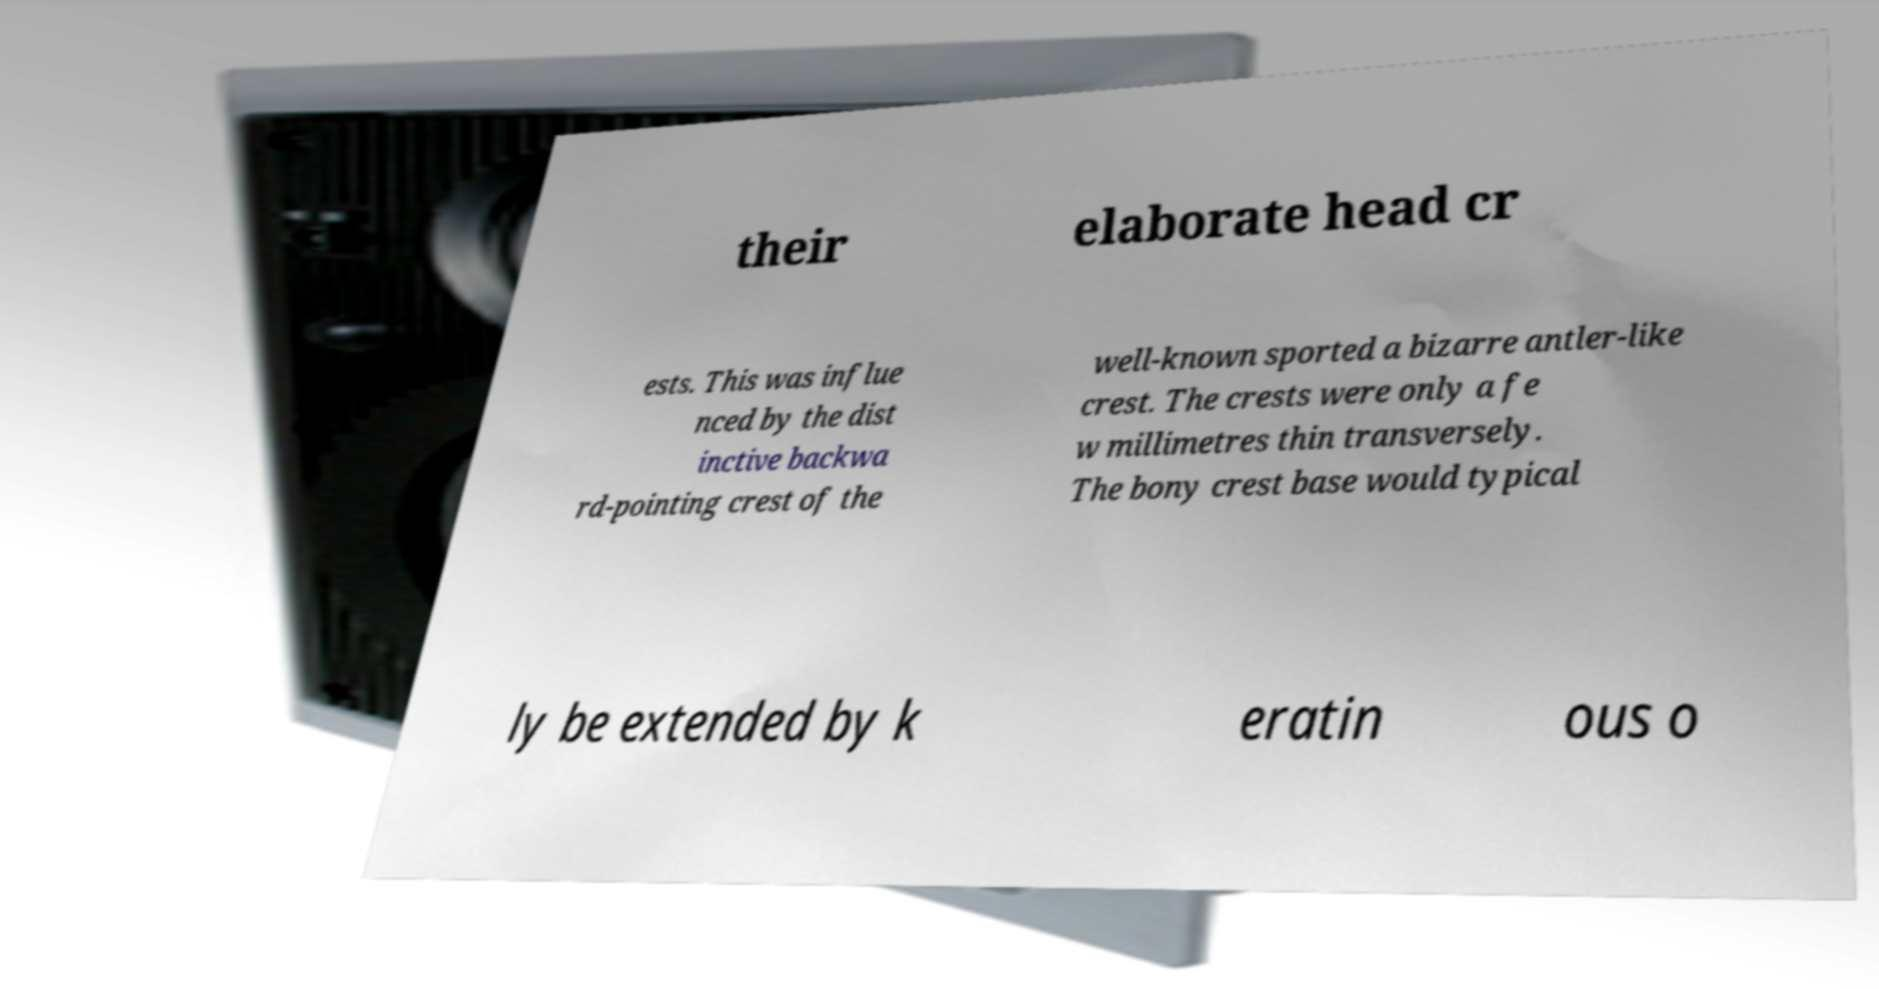Please read and relay the text visible in this image. What does it say? their elaborate head cr ests. This was influe nced by the dist inctive backwa rd-pointing crest of the well-known sported a bizarre antler-like crest. The crests were only a fe w millimetres thin transversely. The bony crest base would typical ly be extended by k eratin ous o 